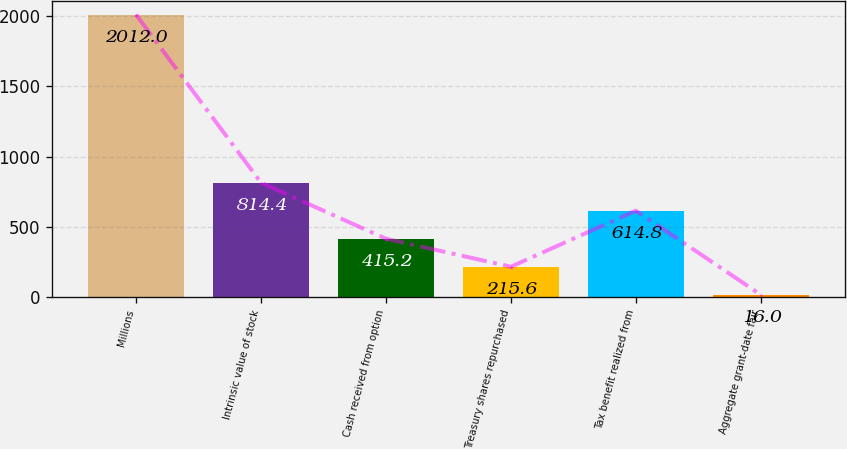Convert chart to OTSL. <chart><loc_0><loc_0><loc_500><loc_500><bar_chart><fcel>Millions<fcel>Intrinsic value of stock<fcel>Cash received from option<fcel>Treasury shares repurchased<fcel>Tax benefit realized from<fcel>Aggregate grant-date fair<nl><fcel>2012<fcel>814.4<fcel>415.2<fcel>215.6<fcel>614.8<fcel>16<nl></chart> 